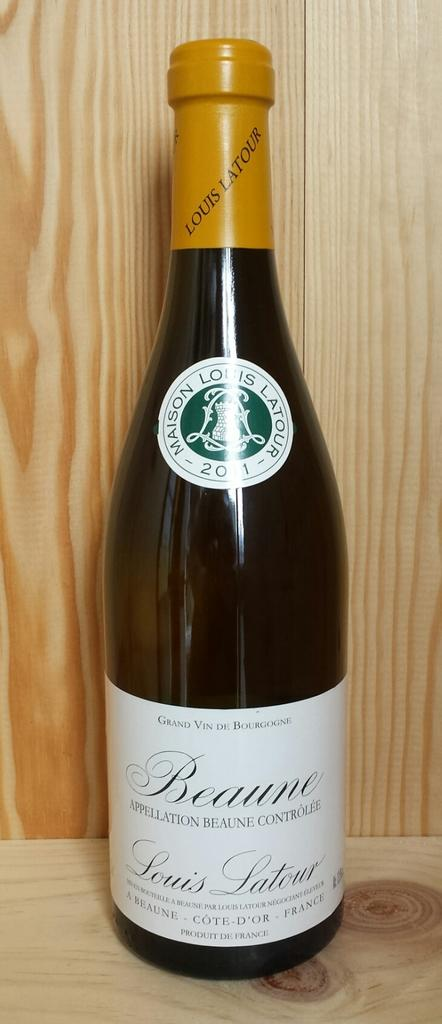<image>
Summarize the visual content of the image. Bottle of Beaune Louis Latour wine from France 